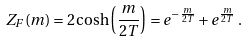Convert formula to latex. <formula><loc_0><loc_0><loc_500><loc_500>Z _ { F } ( m ) = 2 \cosh \left ( \frac { m } { 2 T } \right ) = e ^ { - \frac { m } { 2 T } } + e ^ { \frac { m } { 2 T } } \, .</formula> 